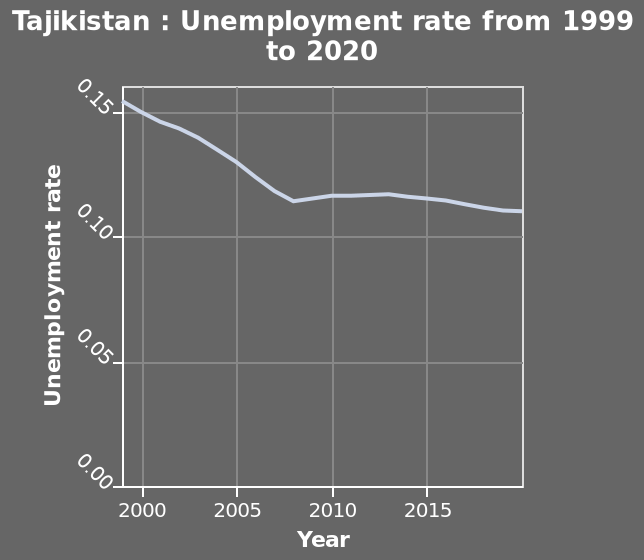<image>
Has there been any change in the unemployment level in Tajikistan in the past 13 years? There has been a slight decrease in the unemployment level in Tajikistan in the past 13 years. Has the unemployment level in Tajikistan remained constant after 2007?  Yes, the unemployment level in Tajikistan has remained fairly constant after 2007. When did the unemployment level in Tajikistan start to stabilize? The unemployment level in Tajikistan started to stabilize after 2007. How long has the unemployment level in Tajikistan been relatively constant? The unemployment level in Tajikistan has been fairly constant for the past 13 years. 